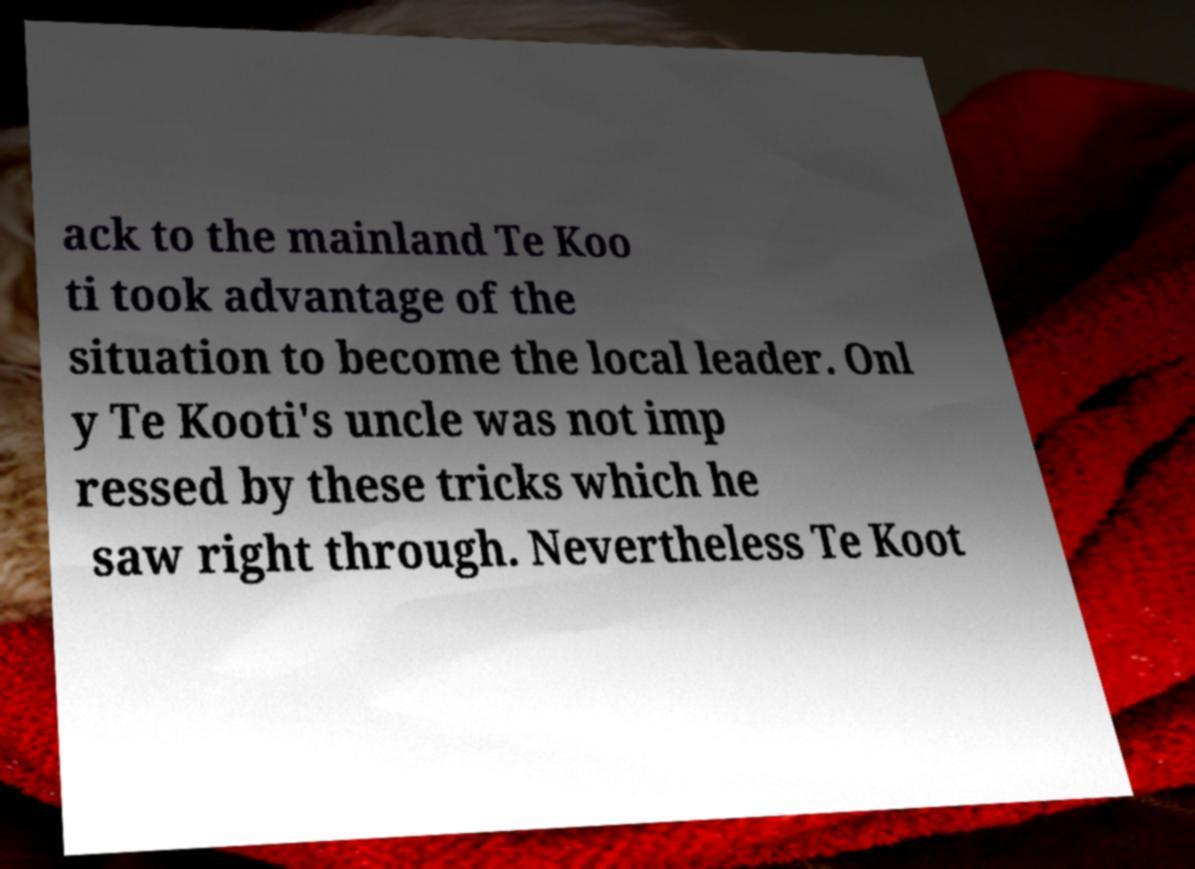Please identify and transcribe the text found in this image. ack to the mainland Te Koo ti took advantage of the situation to become the local leader. Onl y Te Kooti's uncle was not imp ressed by these tricks which he saw right through. Nevertheless Te Koot 